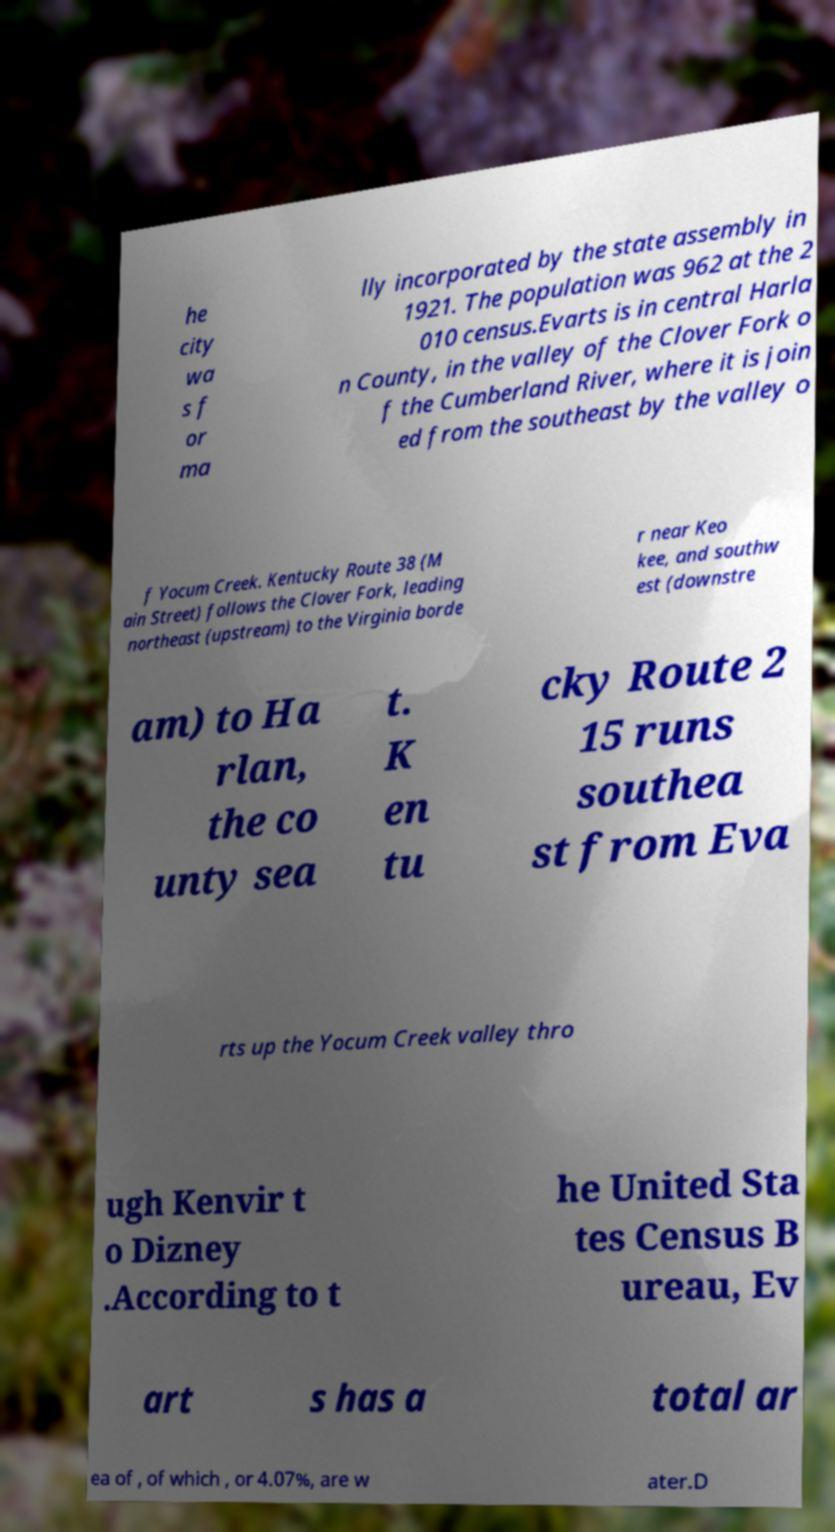I need the written content from this picture converted into text. Can you do that? he city wa s f or ma lly incorporated by the state assembly in 1921. The population was 962 at the 2 010 census.Evarts is in central Harla n County, in the valley of the Clover Fork o f the Cumberland River, where it is join ed from the southeast by the valley o f Yocum Creek. Kentucky Route 38 (M ain Street) follows the Clover Fork, leading northeast (upstream) to the Virginia borde r near Keo kee, and southw est (downstre am) to Ha rlan, the co unty sea t. K en tu cky Route 2 15 runs southea st from Eva rts up the Yocum Creek valley thro ugh Kenvir t o Dizney .According to t he United Sta tes Census B ureau, Ev art s has a total ar ea of , of which , or 4.07%, are w ater.D 